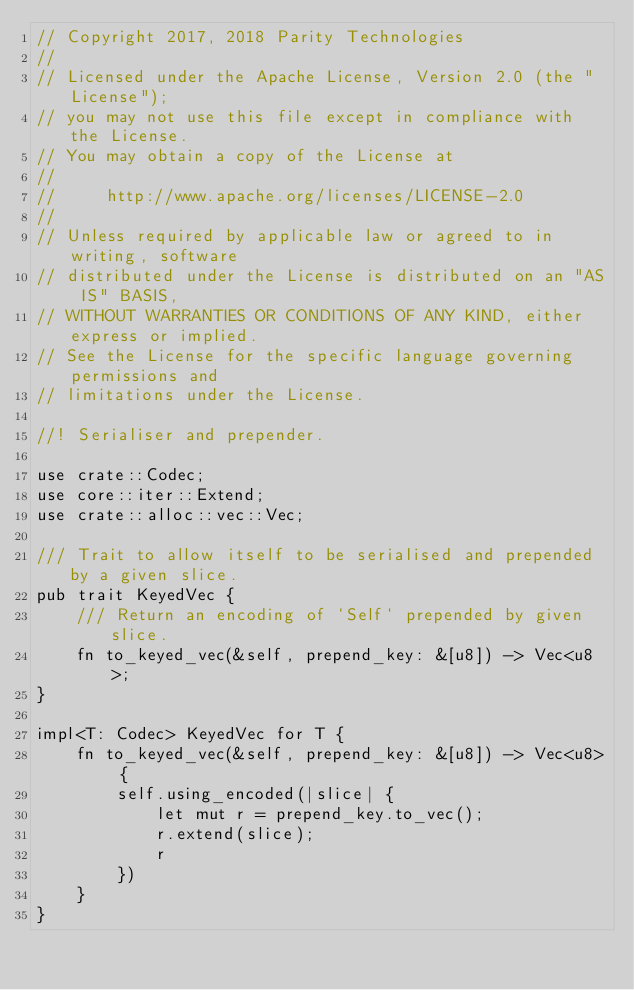Convert code to text. <code><loc_0><loc_0><loc_500><loc_500><_Rust_>// Copyright 2017, 2018 Parity Technologies
//
// Licensed under the Apache License, Version 2.0 (the "License");
// you may not use this file except in compliance with the License.
// You may obtain a copy of the License at
//
//     http://www.apache.org/licenses/LICENSE-2.0
//
// Unless required by applicable law or agreed to in writing, software
// distributed under the License is distributed on an "AS IS" BASIS,
// WITHOUT WARRANTIES OR CONDITIONS OF ANY KIND, either express or implied.
// See the License for the specific language governing permissions and
// limitations under the License.

//! Serialiser and prepender.

use crate::Codec;
use core::iter::Extend;
use crate::alloc::vec::Vec;

/// Trait to allow itself to be serialised and prepended by a given slice.
pub trait KeyedVec {
	/// Return an encoding of `Self` prepended by given slice.
	fn to_keyed_vec(&self, prepend_key: &[u8]) -> Vec<u8>;
}

impl<T: Codec> KeyedVec for T {
	fn to_keyed_vec(&self, prepend_key: &[u8]) -> Vec<u8> {
		self.using_encoded(|slice| {
			let mut r = prepend_key.to_vec();
			r.extend(slice);
			r
		})
	}
}
</code> 